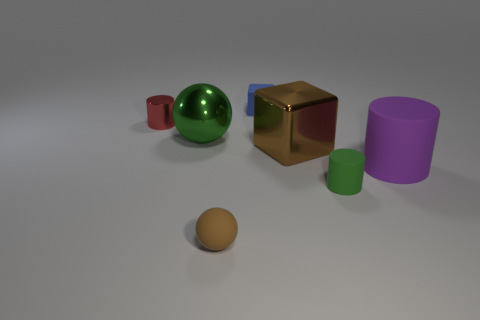Add 2 large shiny balls. How many objects exist? 9 Subtract all balls. How many objects are left? 5 Subtract 0 red spheres. How many objects are left? 7 Subtract all spheres. Subtract all small brown balls. How many objects are left? 4 Add 3 large brown objects. How many large brown objects are left? 4 Add 3 large yellow rubber balls. How many large yellow rubber balls exist? 3 